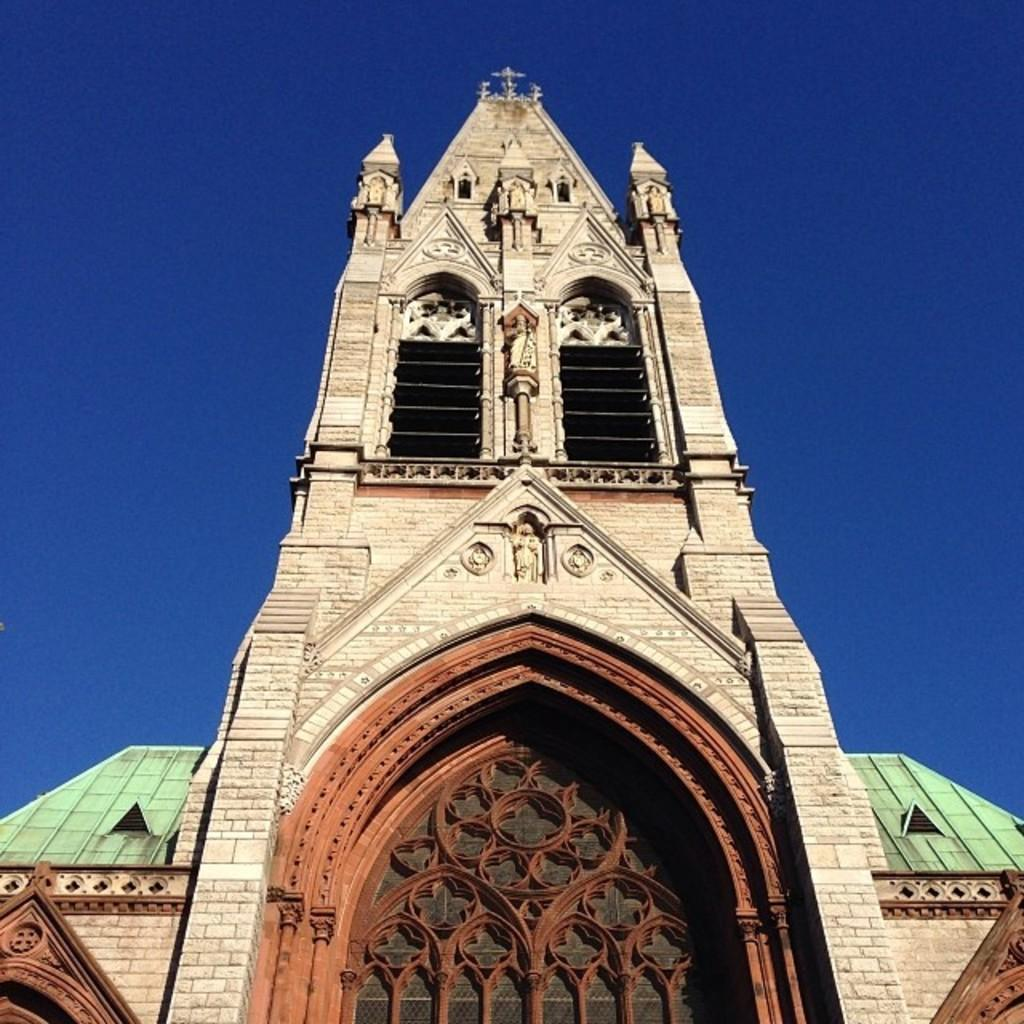What type of structure is present in the image? There is a building in the image. Can you describe any specific features of the building? The building has brown, green, and white colors. What is visible through the window in the image? The sky is visible through the window in the image. What color is the sky in the image? The sky is blue in the image. What type of lace can be seen on the window in the image? There is no lace present on the window in the image. How much milk is visible in the basin in the image? There is no basin or milk present in the image. 